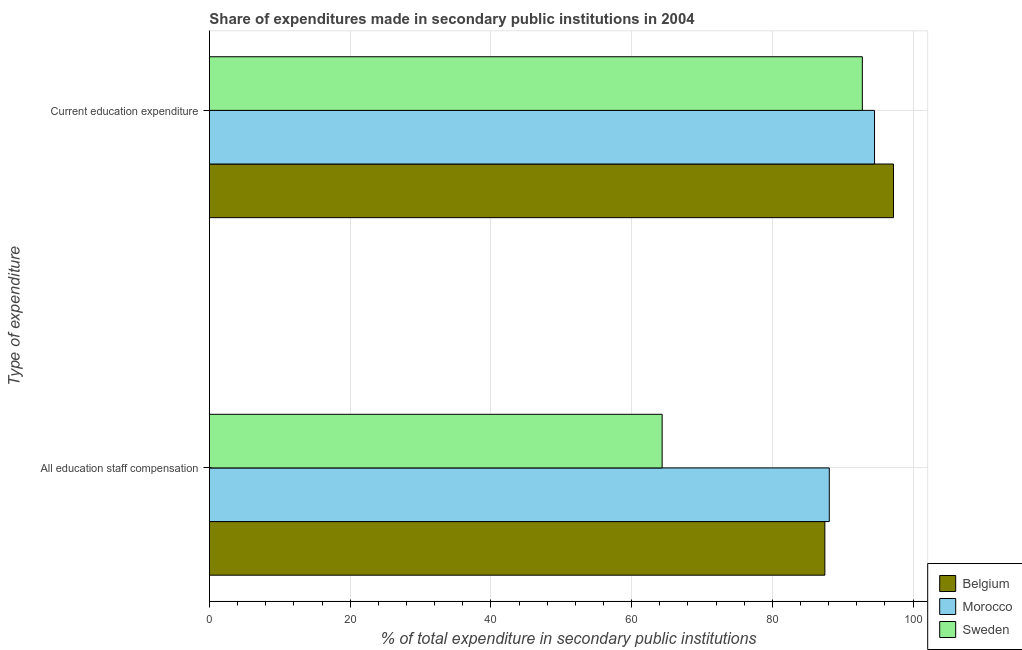How many different coloured bars are there?
Your answer should be compact. 3. Are the number of bars per tick equal to the number of legend labels?
Make the answer very short. Yes. Are the number of bars on each tick of the Y-axis equal?
Provide a short and direct response. Yes. How many bars are there on the 1st tick from the top?
Your answer should be very brief. 3. What is the label of the 1st group of bars from the top?
Your response must be concise. Current education expenditure. What is the expenditure in education in Sweden?
Make the answer very short. 92.79. Across all countries, what is the maximum expenditure in staff compensation?
Make the answer very short. 88.1. Across all countries, what is the minimum expenditure in staff compensation?
Ensure brevity in your answer.  64.34. In which country was the expenditure in staff compensation maximum?
Make the answer very short. Morocco. What is the total expenditure in education in the graph?
Keep it short and to the point. 284.54. What is the difference between the expenditure in staff compensation in Morocco and that in Sweden?
Give a very brief answer. 23.76. What is the difference between the expenditure in staff compensation in Belgium and the expenditure in education in Sweden?
Make the answer very short. -5.33. What is the average expenditure in staff compensation per country?
Give a very brief answer. 79.97. What is the difference between the expenditure in staff compensation and expenditure in education in Sweden?
Provide a succinct answer. -28.45. In how many countries, is the expenditure in staff compensation greater than 92 %?
Offer a very short reply. 0. What is the ratio of the expenditure in education in Belgium to that in Morocco?
Your response must be concise. 1.03. Is the expenditure in staff compensation in Sweden less than that in Morocco?
Your answer should be compact. Yes. In how many countries, is the expenditure in staff compensation greater than the average expenditure in staff compensation taken over all countries?
Offer a terse response. 2. What does the 2nd bar from the top in All education staff compensation represents?
Your answer should be very brief. Morocco. What does the 2nd bar from the bottom in Current education expenditure represents?
Offer a very short reply. Morocco. How many countries are there in the graph?
Make the answer very short. 3. Are the values on the major ticks of X-axis written in scientific E-notation?
Your answer should be very brief. No. How many legend labels are there?
Make the answer very short. 3. How are the legend labels stacked?
Your answer should be very brief. Vertical. What is the title of the graph?
Your answer should be very brief. Share of expenditures made in secondary public institutions in 2004. What is the label or title of the X-axis?
Make the answer very short. % of total expenditure in secondary public institutions. What is the label or title of the Y-axis?
Make the answer very short. Type of expenditure. What is the % of total expenditure in secondary public institutions in Belgium in All education staff compensation?
Offer a very short reply. 87.47. What is the % of total expenditure in secondary public institutions in Morocco in All education staff compensation?
Your response must be concise. 88.1. What is the % of total expenditure in secondary public institutions in Sweden in All education staff compensation?
Provide a short and direct response. 64.34. What is the % of total expenditure in secondary public institutions of Belgium in Current education expenditure?
Keep it short and to the point. 97.22. What is the % of total expenditure in secondary public institutions of Morocco in Current education expenditure?
Ensure brevity in your answer.  94.53. What is the % of total expenditure in secondary public institutions of Sweden in Current education expenditure?
Your response must be concise. 92.79. Across all Type of expenditure, what is the maximum % of total expenditure in secondary public institutions in Belgium?
Provide a succinct answer. 97.22. Across all Type of expenditure, what is the maximum % of total expenditure in secondary public institutions of Morocco?
Offer a very short reply. 94.53. Across all Type of expenditure, what is the maximum % of total expenditure in secondary public institutions in Sweden?
Give a very brief answer. 92.79. Across all Type of expenditure, what is the minimum % of total expenditure in secondary public institutions in Belgium?
Provide a succinct answer. 87.47. Across all Type of expenditure, what is the minimum % of total expenditure in secondary public institutions of Morocco?
Provide a short and direct response. 88.1. Across all Type of expenditure, what is the minimum % of total expenditure in secondary public institutions of Sweden?
Your answer should be compact. 64.34. What is the total % of total expenditure in secondary public institutions of Belgium in the graph?
Offer a terse response. 184.69. What is the total % of total expenditure in secondary public institutions in Morocco in the graph?
Keep it short and to the point. 182.62. What is the total % of total expenditure in secondary public institutions of Sweden in the graph?
Provide a succinct answer. 157.14. What is the difference between the % of total expenditure in secondary public institutions in Belgium in All education staff compensation and that in Current education expenditure?
Keep it short and to the point. -9.75. What is the difference between the % of total expenditure in secondary public institutions in Morocco in All education staff compensation and that in Current education expenditure?
Ensure brevity in your answer.  -6.43. What is the difference between the % of total expenditure in secondary public institutions in Sweden in All education staff compensation and that in Current education expenditure?
Offer a terse response. -28.45. What is the difference between the % of total expenditure in secondary public institutions of Belgium in All education staff compensation and the % of total expenditure in secondary public institutions of Morocco in Current education expenditure?
Your response must be concise. -7.06. What is the difference between the % of total expenditure in secondary public institutions in Belgium in All education staff compensation and the % of total expenditure in secondary public institutions in Sweden in Current education expenditure?
Keep it short and to the point. -5.33. What is the difference between the % of total expenditure in secondary public institutions in Morocco in All education staff compensation and the % of total expenditure in secondary public institutions in Sweden in Current education expenditure?
Give a very brief answer. -4.7. What is the average % of total expenditure in secondary public institutions in Belgium per Type of expenditure?
Offer a terse response. 92.34. What is the average % of total expenditure in secondary public institutions in Morocco per Type of expenditure?
Provide a short and direct response. 91.31. What is the average % of total expenditure in secondary public institutions in Sweden per Type of expenditure?
Make the answer very short. 78.57. What is the difference between the % of total expenditure in secondary public institutions in Belgium and % of total expenditure in secondary public institutions in Morocco in All education staff compensation?
Make the answer very short. -0.63. What is the difference between the % of total expenditure in secondary public institutions in Belgium and % of total expenditure in secondary public institutions in Sweden in All education staff compensation?
Give a very brief answer. 23.13. What is the difference between the % of total expenditure in secondary public institutions of Morocco and % of total expenditure in secondary public institutions of Sweden in All education staff compensation?
Your response must be concise. 23.76. What is the difference between the % of total expenditure in secondary public institutions of Belgium and % of total expenditure in secondary public institutions of Morocco in Current education expenditure?
Provide a succinct answer. 2.69. What is the difference between the % of total expenditure in secondary public institutions in Belgium and % of total expenditure in secondary public institutions in Sweden in Current education expenditure?
Keep it short and to the point. 4.43. What is the difference between the % of total expenditure in secondary public institutions of Morocco and % of total expenditure in secondary public institutions of Sweden in Current education expenditure?
Your answer should be very brief. 1.73. What is the ratio of the % of total expenditure in secondary public institutions of Belgium in All education staff compensation to that in Current education expenditure?
Offer a terse response. 0.9. What is the ratio of the % of total expenditure in secondary public institutions in Morocco in All education staff compensation to that in Current education expenditure?
Offer a very short reply. 0.93. What is the ratio of the % of total expenditure in secondary public institutions in Sweden in All education staff compensation to that in Current education expenditure?
Your answer should be very brief. 0.69. What is the difference between the highest and the second highest % of total expenditure in secondary public institutions of Belgium?
Offer a terse response. 9.75. What is the difference between the highest and the second highest % of total expenditure in secondary public institutions in Morocco?
Give a very brief answer. 6.43. What is the difference between the highest and the second highest % of total expenditure in secondary public institutions in Sweden?
Give a very brief answer. 28.45. What is the difference between the highest and the lowest % of total expenditure in secondary public institutions in Belgium?
Your response must be concise. 9.75. What is the difference between the highest and the lowest % of total expenditure in secondary public institutions in Morocco?
Your answer should be very brief. 6.43. What is the difference between the highest and the lowest % of total expenditure in secondary public institutions of Sweden?
Offer a terse response. 28.45. 